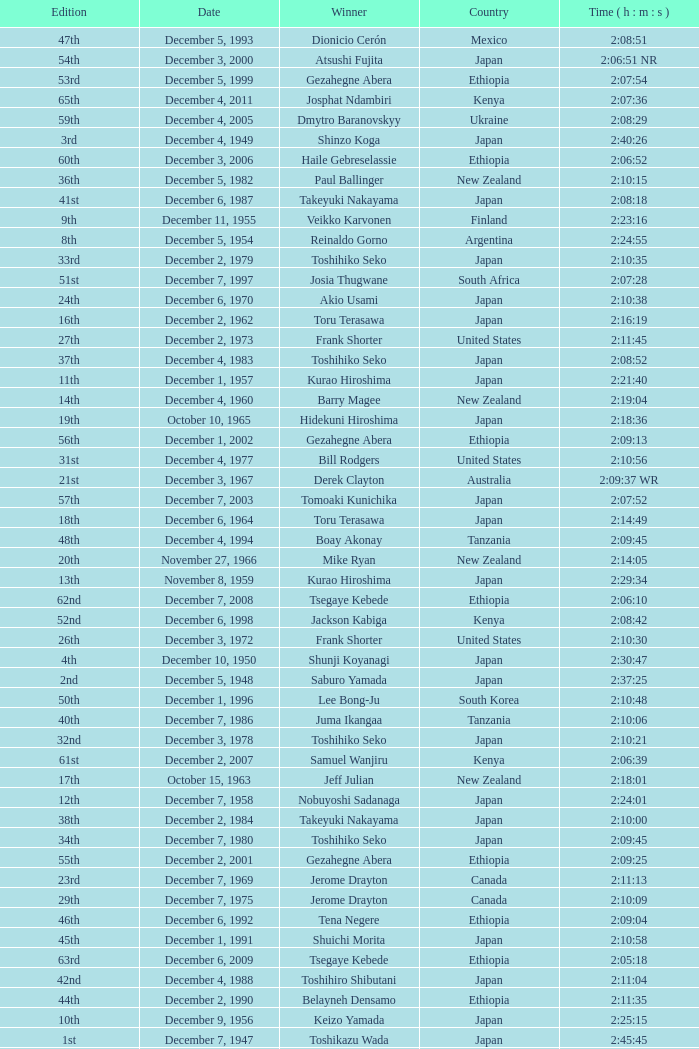On what date did Lee Bong-Ju win in 2:10:48? December 1, 1996. 